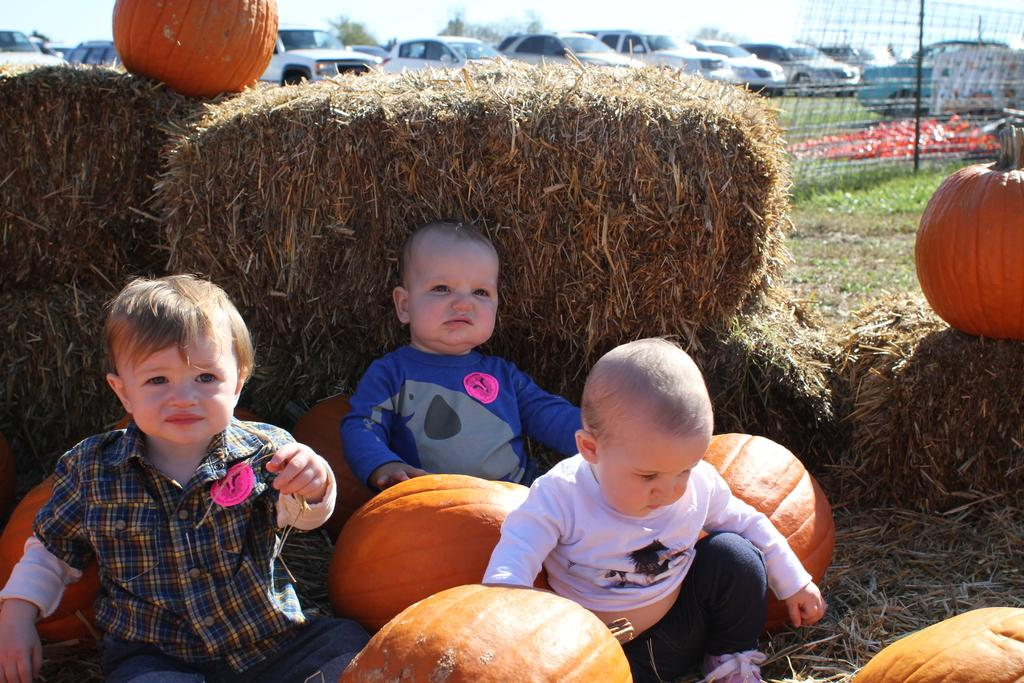Who is present in the image? There are kids in the image. What objects are associated with the kids in the image? There are pumpkins in the image. What can be seen in the background of the image? There is a fence, grass, vehicles, and the sky visible in the background of the image. What type of soup is being served in the image? There is no soup present in the image. What material is the brass used for in the image? There is: There is no brass present in the image. 